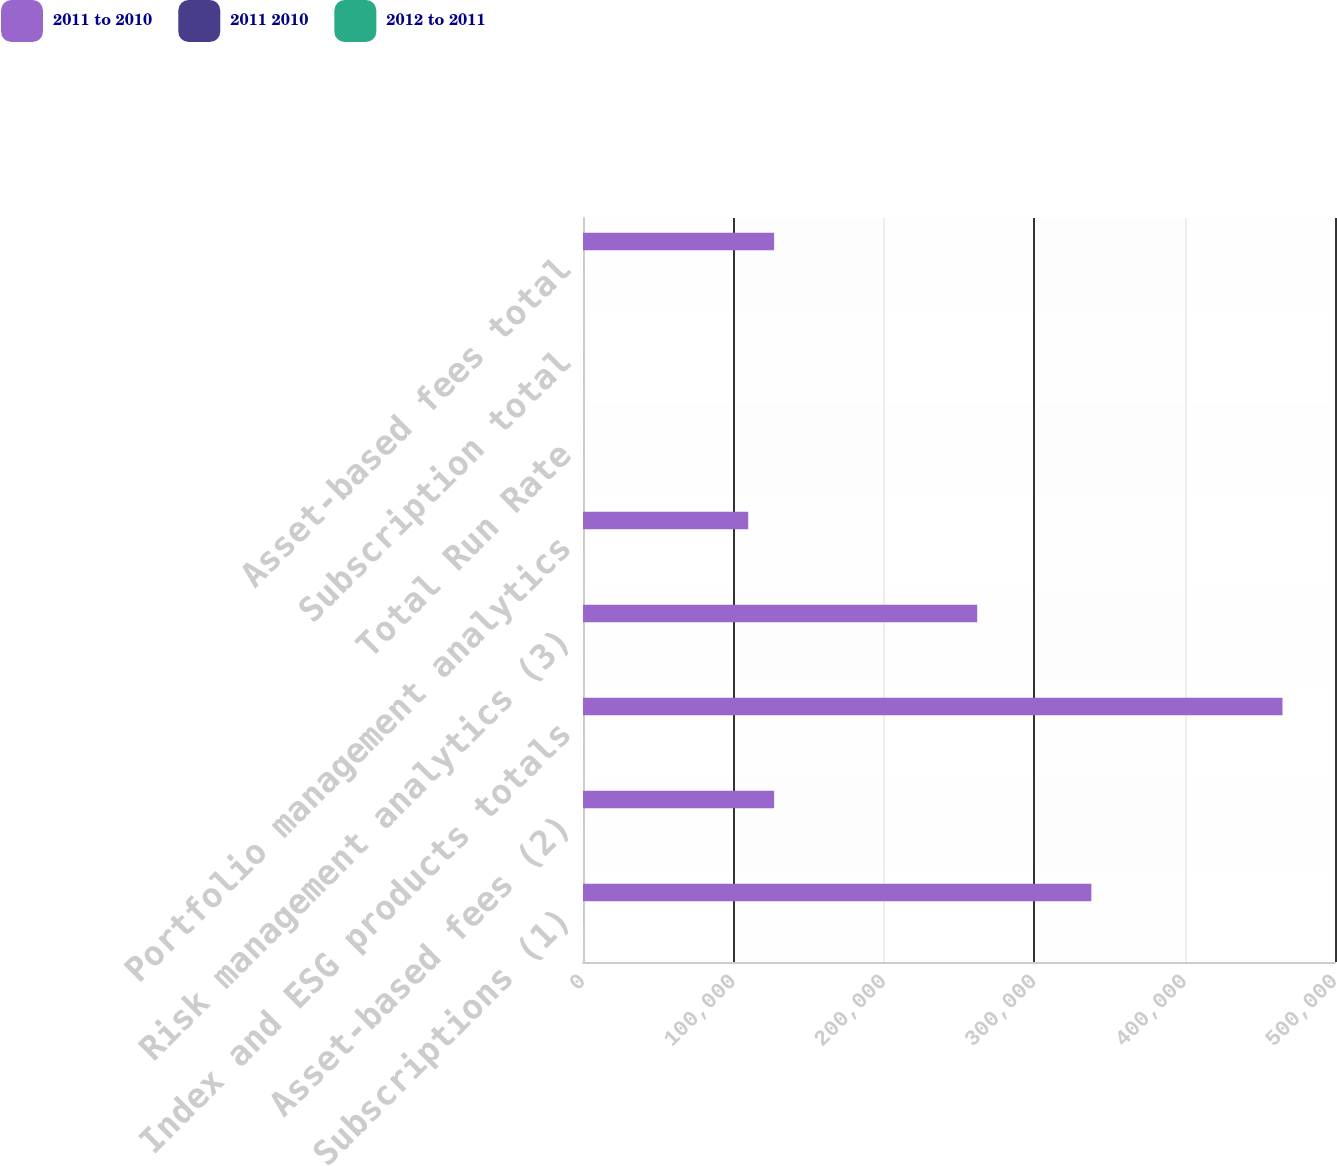<chart> <loc_0><loc_0><loc_500><loc_500><stacked_bar_chart><ecel><fcel>Subscriptions (1)<fcel>Asset-based fees (2)<fcel>Index and ESG products totals<fcel>Risk management analytics (3)<fcel>Portfolio management analytics<fcel>Total Run Rate<fcel>Subscription total<fcel>Asset-based fees total<nl><fcel>2011 to 2010<fcel>338006<fcel>127072<fcel>465078<fcel>262108<fcel>109836<fcel>9.85<fcel>9.85<fcel>127072<nl><fcel>2011 2010<fcel>25.3<fcel>6.2<fcel>19.4<fcel>4.4<fcel>7.2<fcel>9.7<fcel>10.2<fcel>6.2<nl><fcel>2012 to 2011<fcel>14.2<fcel>1.6<fcel>10<fcel>7.5<fcel>2.8<fcel>7.2<fcel>8.1<fcel>1.6<nl></chart> 